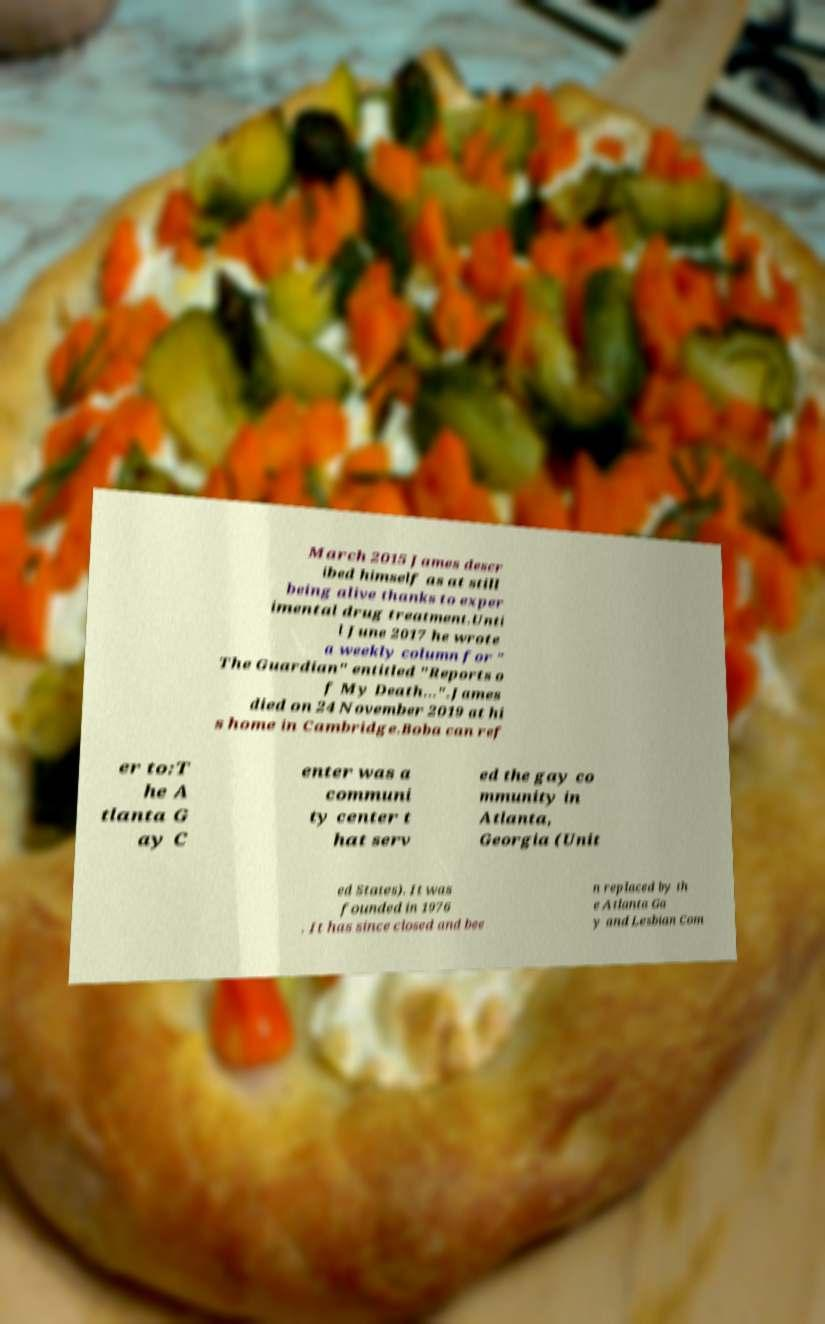Can you read and provide the text displayed in the image?This photo seems to have some interesting text. Can you extract and type it out for me? March 2015 James descr ibed himself as at still being alive thanks to exper imental drug treatment.Unti l June 2017 he wrote a weekly column for " The Guardian" entitled "Reports o f My Death...".James died on 24 November 2019 at hi s home in Cambridge.Boba can ref er to:T he A tlanta G ay C enter was a communi ty center t hat serv ed the gay co mmunity in Atlanta, Georgia (Unit ed States). It was founded in 1976 . It has since closed and bee n replaced by th e Atlanta Ga y and Lesbian Com 